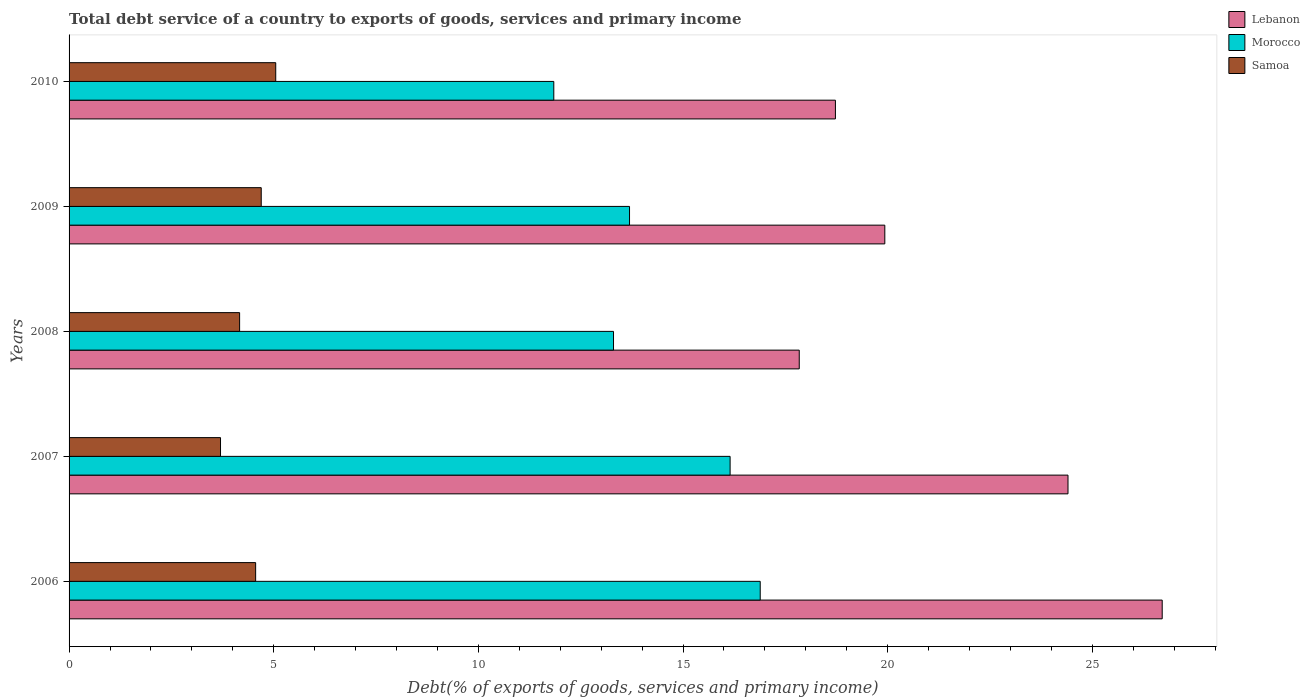How many different coloured bars are there?
Keep it short and to the point. 3. Are the number of bars per tick equal to the number of legend labels?
Ensure brevity in your answer.  Yes. Are the number of bars on each tick of the Y-axis equal?
Your answer should be compact. Yes. How many bars are there on the 1st tick from the top?
Your answer should be very brief. 3. How many bars are there on the 3rd tick from the bottom?
Your answer should be compact. 3. What is the label of the 2nd group of bars from the top?
Your answer should be very brief. 2009. What is the total debt service in Morocco in 2007?
Offer a terse response. 16.15. Across all years, what is the maximum total debt service in Morocco?
Ensure brevity in your answer.  16.89. Across all years, what is the minimum total debt service in Samoa?
Ensure brevity in your answer.  3.7. In which year was the total debt service in Morocco minimum?
Provide a short and direct response. 2010. What is the total total debt service in Morocco in the graph?
Offer a terse response. 71.88. What is the difference between the total debt service in Samoa in 2006 and that in 2007?
Your answer should be very brief. 0.86. What is the difference between the total debt service in Samoa in 2008 and the total debt service in Lebanon in 2007?
Offer a very short reply. -20.24. What is the average total debt service in Lebanon per year?
Your answer should be compact. 21.52. In the year 2010, what is the difference between the total debt service in Samoa and total debt service in Morocco?
Keep it short and to the point. -6.79. What is the ratio of the total debt service in Lebanon in 2008 to that in 2010?
Keep it short and to the point. 0.95. Is the total debt service in Samoa in 2008 less than that in 2010?
Your answer should be compact. Yes. Is the difference between the total debt service in Samoa in 2007 and 2010 greater than the difference between the total debt service in Morocco in 2007 and 2010?
Provide a succinct answer. No. What is the difference between the highest and the second highest total debt service in Lebanon?
Your answer should be compact. 2.3. What is the difference between the highest and the lowest total debt service in Morocco?
Your response must be concise. 5.04. Is the sum of the total debt service in Lebanon in 2006 and 2010 greater than the maximum total debt service in Samoa across all years?
Your response must be concise. Yes. What does the 3rd bar from the top in 2006 represents?
Provide a short and direct response. Lebanon. What does the 3rd bar from the bottom in 2007 represents?
Give a very brief answer. Samoa. Is it the case that in every year, the sum of the total debt service in Morocco and total debt service in Samoa is greater than the total debt service in Lebanon?
Offer a terse response. No. How many bars are there?
Keep it short and to the point. 15. What is the difference between two consecutive major ticks on the X-axis?
Keep it short and to the point. 5. Are the values on the major ticks of X-axis written in scientific E-notation?
Keep it short and to the point. No. Where does the legend appear in the graph?
Ensure brevity in your answer.  Top right. What is the title of the graph?
Your response must be concise. Total debt service of a country to exports of goods, services and primary income. What is the label or title of the X-axis?
Your answer should be compact. Debt(% of exports of goods, services and primary income). What is the label or title of the Y-axis?
Offer a terse response. Years. What is the Debt(% of exports of goods, services and primary income) of Lebanon in 2006?
Offer a very short reply. 26.71. What is the Debt(% of exports of goods, services and primary income) in Morocco in 2006?
Your answer should be compact. 16.89. What is the Debt(% of exports of goods, services and primary income) in Samoa in 2006?
Offer a very short reply. 4.56. What is the Debt(% of exports of goods, services and primary income) of Lebanon in 2007?
Give a very brief answer. 24.41. What is the Debt(% of exports of goods, services and primary income) in Morocco in 2007?
Give a very brief answer. 16.15. What is the Debt(% of exports of goods, services and primary income) of Samoa in 2007?
Give a very brief answer. 3.7. What is the Debt(% of exports of goods, services and primary income) in Lebanon in 2008?
Provide a short and direct response. 17.84. What is the Debt(% of exports of goods, services and primary income) of Morocco in 2008?
Your response must be concise. 13.3. What is the Debt(% of exports of goods, services and primary income) of Samoa in 2008?
Provide a short and direct response. 4.17. What is the Debt(% of exports of goods, services and primary income) in Lebanon in 2009?
Your response must be concise. 19.93. What is the Debt(% of exports of goods, services and primary income) of Morocco in 2009?
Give a very brief answer. 13.69. What is the Debt(% of exports of goods, services and primary income) of Samoa in 2009?
Make the answer very short. 4.7. What is the Debt(% of exports of goods, services and primary income) of Lebanon in 2010?
Offer a very short reply. 18.72. What is the Debt(% of exports of goods, services and primary income) of Morocco in 2010?
Your answer should be compact. 11.84. What is the Debt(% of exports of goods, services and primary income) in Samoa in 2010?
Offer a terse response. 5.05. Across all years, what is the maximum Debt(% of exports of goods, services and primary income) of Lebanon?
Keep it short and to the point. 26.71. Across all years, what is the maximum Debt(% of exports of goods, services and primary income) in Morocco?
Keep it short and to the point. 16.89. Across all years, what is the maximum Debt(% of exports of goods, services and primary income) of Samoa?
Your response must be concise. 5.05. Across all years, what is the minimum Debt(% of exports of goods, services and primary income) of Lebanon?
Offer a terse response. 17.84. Across all years, what is the minimum Debt(% of exports of goods, services and primary income) in Morocco?
Your answer should be compact. 11.84. Across all years, what is the minimum Debt(% of exports of goods, services and primary income) of Samoa?
Give a very brief answer. 3.7. What is the total Debt(% of exports of goods, services and primary income) in Lebanon in the graph?
Provide a short and direct response. 107.61. What is the total Debt(% of exports of goods, services and primary income) in Morocco in the graph?
Your response must be concise. 71.88. What is the total Debt(% of exports of goods, services and primary income) in Samoa in the graph?
Offer a terse response. 22.17. What is the difference between the Debt(% of exports of goods, services and primary income) of Lebanon in 2006 and that in 2007?
Offer a very short reply. 2.3. What is the difference between the Debt(% of exports of goods, services and primary income) in Morocco in 2006 and that in 2007?
Offer a terse response. 0.74. What is the difference between the Debt(% of exports of goods, services and primary income) in Samoa in 2006 and that in 2007?
Ensure brevity in your answer.  0.86. What is the difference between the Debt(% of exports of goods, services and primary income) of Lebanon in 2006 and that in 2008?
Ensure brevity in your answer.  8.87. What is the difference between the Debt(% of exports of goods, services and primary income) of Morocco in 2006 and that in 2008?
Offer a very short reply. 3.58. What is the difference between the Debt(% of exports of goods, services and primary income) of Samoa in 2006 and that in 2008?
Make the answer very short. 0.39. What is the difference between the Debt(% of exports of goods, services and primary income) of Lebanon in 2006 and that in 2009?
Offer a very short reply. 6.78. What is the difference between the Debt(% of exports of goods, services and primary income) of Morocco in 2006 and that in 2009?
Offer a terse response. 3.19. What is the difference between the Debt(% of exports of goods, services and primary income) of Samoa in 2006 and that in 2009?
Offer a terse response. -0.14. What is the difference between the Debt(% of exports of goods, services and primary income) of Lebanon in 2006 and that in 2010?
Offer a very short reply. 7.98. What is the difference between the Debt(% of exports of goods, services and primary income) of Morocco in 2006 and that in 2010?
Your response must be concise. 5.04. What is the difference between the Debt(% of exports of goods, services and primary income) of Samoa in 2006 and that in 2010?
Give a very brief answer. -0.49. What is the difference between the Debt(% of exports of goods, services and primary income) of Lebanon in 2007 and that in 2008?
Ensure brevity in your answer.  6.57. What is the difference between the Debt(% of exports of goods, services and primary income) of Morocco in 2007 and that in 2008?
Keep it short and to the point. 2.85. What is the difference between the Debt(% of exports of goods, services and primary income) in Samoa in 2007 and that in 2008?
Offer a very short reply. -0.47. What is the difference between the Debt(% of exports of goods, services and primary income) of Lebanon in 2007 and that in 2009?
Your response must be concise. 4.48. What is the difference between the Debt(% of exports of goods, services and primary income) of Morocco in 2007 and that in 2009?
Ensure brevity in your answer.  2.46. What is the difference between the Debt(% of exports of goods, services and primary income) of Samoa in 2007 and that in 2009?
Give a very brief answer. -0.99. What is the difference between the Debt(% of exports of goods, services and primary income) of Lebanon in 2007 and that in 2010?
Offer a very short reply. 5.68. What is the difference between the Debt(% of exports of goods, services and primary income) in Morocco in 2007 and that in 2010?
Ensure brevity in your answer.  4.31. What is the difference between the Debt(% of exports of goods, services and primary income) in Samoa in 2007 and that in 2010?
Provide a short and direct response. -1.35. What is the difference between the Debt(% of exports of goods, services and primary income) in Lebanon in 2008 and that in 2009?
Offer a terse response. -2.09. What is the difference between the Debt(% of exports of goods, services and primary income) in Morocco in 2008 and that in 2009?
Your answer should be compact. -0.39. What is the difference between the Debt(% of exports of goods, services and primary income) of Samoa in 2008 and that in 2009?
Provide a short and direct response. -0.53. What is the difference between the Debt(% of exports of goods, services and primary income) of Lebanon in 2008 and that in 2010?
Ensure brevity in your answer.  -0.88. What is the difference between the Debt(% of exports of goods, services and primary income) in Morocco in 2008 and that in 2010?
Provide a succinct answer. 1.46. What is the difference between the Debt(% of exports of goods, services and primary income) of Samoa in 2008 and that in 2010?
Make the answer very short. -0.88. What is the difference between the Debt(% of exports of goods, services and primary income) in Lebanon in 2009 and that in 2010?
Offer a very short reply. 1.21. What is the difference between the Debt(% of exports of goods, services and primary income) of Morocco in 2009 and that in 2010?
Make the answer very short. 1.85. What is the difference between the Debt(% of exports of goods, services and primary income) in Samoa in 2009 and that in 2010?
Give a very brief answer. -0.35. What is the difference between the Debt(% of exports of goods, services and primary income) of Lebanon in 2006 and the Debt(% of exports of goods, services and primary income) of Morocco in 2007?
Ensure brevity in your answer.  10.56. What is the difference between the Debt(% of exports of goods, services and primary income) of Lebanon in 2006 and the Debt(% of exports of goods, services and primary income) of Samoa in 2007?
Your answer should be very brief. 23.01. What is the difference between the Debt(% of exports of goods, services and primary income) of Morocco in 2006 and the Debt(% of exports of goods, services and primary income) of Samoa in 2007?
Ensure brevity in your answer.  13.19. What is the difference between the Debt(% of exports of goods, services and primary income) of Lebanon in 2006 and the Debt(% of exports of goods, services and primary income) of Morocco in 2008?
Provide a succinct answer. 13.41. What is the difference between the Debt(% of exports of goods, services and primary income) of Lebanon in 2006 and the Debt(% of exports of goods, services and primary income) of Samoa in 2008?
Your answer should be compact. 22.54. What is the difference between the Debt(% of exports of goods, services and primary income) in Morocco in 2006 and the Debt(% of exports of goods, services and primary income) in Samoa in 2008?
Offer a very short reply. 12.72. What is the difference between the Debt(% of exports of goods, services and primary income) of Lebanon in 2006 and the Debt(% of exports of goods, services and primary income) of Morocco in 2009?
Your answer should be compact. 13.01. What is the difference between the Debt(% of exports of goods, services and primary income) of Lebanon in 2006 and the Debt(% of exports of goods, services and primary income) of Samoa in 2009?
Your response must be concise. 22.01. What is the difference between the Debt(% of exports of goods, services and primary income) in Morocco in 2006 and the Debt(% of exports of goods, services and primary income) in Samoa in 2009?
Your answer should be very brief. 12.19. What is the difference between the Debt(% of exports of goods, services and primary income) of Lebanon in 2006 and the Debt(% of exports of goods, services and primary income) of Morocco in 2010?
Provide a succinct answer. 14.86. What is the difference between the Debt(% of exports of goods, services and primary income) of Lebanon in 2006 and the Debt(% of exports of goods, services and primary income) of Samoa in 2010?
Provide a short and direct response. 21.66. What is the difference between the Debt(% of exports of goods, services and primary income) of Morocco in 2006 and the Debt(% of exports of goods, services and primary income) of Samoa in 2010?
Give a very brief answer. 11.84. What is the difference between the Debt(% of exports of goods, services and primary income) in Lebanon in 2007 and the Debt(% of exports of goods, services and primary income) in Morocco in 2008?
Provide a succinct answer. 11.1. What is the difference between the Debt(% of exports of goods, services and primary income) in Lebanon in 2007 and the Debt(% of exports of goods, services and primary income) in Samoa in 2008?
Provide a succinct answer. 20.24. What is the difference between the Debt(% of exports of goods, services and primary income) of Morocco in 2007 and the Debt(% of exports of goods, services and primary income) of Samoa in 2008?
Provide a short and direct response. 11.98. What is the difference between the Debt(% of exports of goods, services and primary income) in Lebanon in 2007 and the Debt(% of exports of goods, services and primary income) in Morocco in 2009?
Offer a very short reply. 10.71. What is the difference between the Debt(% of exports of goods, services and primary income) in Lebanon in 2007 and the Debt(% of exports of goods, services and primary income) in Samoa in 2009?
Provide a succinct answer. 19.71. What is the difference between the Debt(% of exports of goods, services and primary income) in Morocco in 2007 and the Debt(% of exports of goods, services and primary income) in Samoa in 2009?
Make the answer very short. 11.46. What is the difference between the Debt(% of exports of goods, services and primary income) in Lebanon in 2007 and the Debt(% of exports of goods, services and primary income) in Morocco in 2010?
Provide a short and direct response. 12.56. What is the difference between the Debt(% of exports of goods, services and primary income) of Lebanon in 2007 and the Debt(% of exports of goods, services and primary income) of Samoa in 2010?
Offer a very short reply. 19.36. What is the difference between the Debt(% of exports of goods, services and primary income) in Morocco in 2007 and the Debt(% of exports of goods, services and primary income) in Samoa in 2010?
Provide a succinct answer. 11.1. What is the difference between the Debt(% of exports of goods, services and primary income) in Lebanon in 2008 and the Debt(% of exports of goods, services and primary income) in Morocco in 2009?
Your response must be concise. 4.15. What is the difference between the Debt(% of exports of goods, services and primary income) in Lebanon in 2008 and the Debt(% of exports of goods, services and primary income) in Samoa in 2009?
Provide a short and direct response. 13.15. What is the difference between the Debt(% of exports of goods, services and primary income) in Morocco in 2008 and the Debt(% of exports of goods, services and primary income) in Samoa in 2009?
Make the answer very short. 8.61. What is the difference between the Debt(% of exports of goods, services and primary income) in Lebanon in 2008 and the Debt(% of exports of goods, services and primary income) in Morocco in 2010?
Your answer should be very brief. 6. What is the difference between the Debt(% of exports of goods, services and primary income) in Lebanon in 2008 and the Debt(% of exports of goods, services and primary income) in Samoa in 2010?
Your answer should be compact. 12.79. What is the difference between the Debt(% of exports of goods, services and primary income) in Morocco in 2008 and the Debt(% of exports of goods, services and primary income) in Samoa in 2010?
Your answer should be compact. 8.25. What is the difference between the Debt(% of exports of goods, services and primary income) in Lebanon in 2009 and the Debt(% of exports of goods, services and primary income) in Morocco in 2010?
Make the answer very short. 8.09. What is the difference between the Debt(% of exports of goods, services and primary income) of Lebanon in 2009 and the Debt(% of exports of goods, services and primary income) of Samoa in 2010?
Make the answer very short. 14.88. What is the difference between the Debt(% of exports of goods, services and primary income) in Morocco in 2009 and the Debt(% of exports of goods, services and primary income) in Samoa in 2010?
Ensure brevity in your answer.  8.64. What is the average Debt(% of exports of goods, services and primary income) in Lebanon per year?
Offer a very short reply. 21.52. What is the average Debt(% of exports of goods, services and primary income) of Morocco per year?
Make the answer very short. 14.38. What is the average Debt(% of exports of goods, services and primary income) of Samoa per year?
Your answer should be compact. 4.43. In the year 2006, what is the difference between the Debt(% of exports of goods, services and primary income) of Lebanon and Debt(% of exports of goods, services and primary income) of Morocco?
Ensure brevity in your answer.  9.82. In the year 2006, what is the difference between the Debt(% of exports of goods, services and primary income) in Lebanon and Debt(% of exports of goods, services and primary income) in Samoa?
Your answer should be very brief. 22.15. In the year 2006, what is the difference between the Debt(% of exports of goods, services and primary income) of Morocco and Debt(% of exports of goods, services and primary income) of Samoa?
Make the answer very short. 12.33. In the year 2007, what is the difference between the Debt(% of exports of goods, services and primary income) of Lebanon and Debt(% of exports of goods, services and primary income) of Morocco?
Offer a very short reply. 8.26. In the year 2007, what is the difference between the Debt(% of exports of goods, services and primary income) in Lebanon and Debt(% of exports of goods, services and primary income) in Samoa?
Offer a very short reply. 20.71. In the year 2007, what is the difference between the Debt(% of exports of goods, services and primary income) in Morocco and Debt(% of exports of goods, services and primary income) in Samoa?
Your answer should be compact. 12.45. In the year 2008, what is the difference between the Debt(% of exports of goods, services and primary income) of Lebanon and Debt(% of exports of goods, services and primary income) of Morocco?
Offer a terse response. 4.54. In the year 2008, what is the difference between the Debt(% of exports of goods, services and primary income) in Lebanon and Debt(% of exports of goods, services and primary income) in Samoa?
Your answer should be very brief. 13.67. In the year 2008, what is the difference between the Debt(% of exports of goods, services and primary income) in Morocco and Debt(% of exports of goods, services and primary income) in Samoa?
Give a very brief answer. 9.14. In the year 2009, what is the difference between the Debt(% of exports of goods, services and primary income) of Lebanon and Debt(% of exports of goods, services and primary income) of Morocco?
Provide a succinct answer. 6.24. In the year 2009, what is the difference between the Debt(% of exports of goods, services and primary income) in Lebanon and Debt(% of exports of goods, services and primary income) in Samoa?
Give a very brief answer. 15.24. In the year 2009, what is the difference between the Debt(% of exports of goods, services and primary income) in Morocco and Debt(% of exports of goods, services and primary income) in Samoa?
Give a very brief answer. 9. In the year 2010, what is the difference between the Debt(% of exports of goods, services and primary income) in Lebanon and Debt(% of exports of goods, services and primary income) in Morocco?
Keep it short and to the point. 6.88. In the year 2010, what is the difference between the Debt(% of exports of goods, services and primary income) of Lebanon and Debt(% of exports of goods, services and primary income) of Samoa?
Make the answer very short. 13.67. In the year 2010, what is the difference between the Debt(% of exports of goods, services and primary income) in Morocco and Debt(% of exports of goods, services and primary income) in Samoa?
Make the answer very short. 6.79. What is the ratio of the Debt(% of exports of goods, services and primary income) of Lebanon in 2006 to that in 2007?
Provide a short and direct response. 1.09. What is the ratio of the Debt(% of exports of goods, services and primary income) in Morocco in 2006 to that in 2007?
Provide a succinct answer. 1.05. What is the ratio of the Debt(% of exports of goods, services and primary income) in Samoa in 2006 to that in 2007?
Provide a succinct answer. 1.23. What is the ratio of the Debt(% of exports of goods, services and primary income) in Lebanon in 2006 to that in 2008?
Ensure brevity in your answer.  1.5. What is the ratio of the Debt(% of exports of goods, services and primary income) of Morocco in 2006 to that in 2008?
Provide a succinct answer. 1.27. What is the ratio of the Debt(% of exports of goods, services and primary income) in Samoa in 2006 to that in 2008?
Give a very brief answer. 1.09. What is the ratio of the Debt(% of exports of goods, services and primary income) of Lebanon in 2006 to that in 2009?
Your answer should be compact. 1.34. What is the ratio of the Debt(% of exports of goods, services and primary income) in Morocco in 2006 to that in 2009?
Offer a very short reply. 1.23. What is the ratio of the Debt(% of exports of goods, services and primary income) of Samoa in 2006 to that in 2009?
Ensure brevity in your answer.  0.97. What is the ratio of the Debt(% of exports of goods, services and primary income) of Lebanon in 2006 to that in 2010?
Provide a short and direct response. 1.43. What is the ratio of the Debt(% of exports of goods, services and primary income) in Morocco in 2006 to that in 2010?
Provide a succinct answer. 1.43. What is the ratio of the Debt(% of exports of goods, services and primary income) in Samoa in 2006 to that in 2010?
Give a very brief answer. 0.9. What is the ratio of the Debt(% of exports of goods, services and primary income) of Lebanon in 2007 to that in 2008?
Make the answer very short. 1.37. What is the ratio of the Debt(% of exports of goods, services and primary income) of Morocco in 2007 to that in 2008?
Offer a terse response. 1.21. What is the ratio of the Debt(% of exports of goods, services and primary income) of Samoa in 2007 to that in 2008?
Make the answer very short. 0.89. What is the ratio of the Debt(% of exports of goods, services and primary income) in Lebanon in 2007 to that in 2009?
Offer a very short reply. 1.22. What is the ratio of the Debt(% of exports of goods, services and primary income) in Morocco in 2007 to that in 2009?
Give a very brief answer. 1.18. What is the ratio of the Debt(% of exports of goods, services and primary income) of Samoa in 2007 to that in 2009?
Ensure brevity in your answer.  0.79. What is the ratio of the Debt(% of exports of goods, services and primary income) in Lebanon in 2007 to that in 2010?
Provide a short and direct response. 1.3. What is the ratio of the Debt(% of exports of goods, services and primary income) in Morocco in 2007 to that in 2010?
Ensure brevity in your answer.  1.36. What is the ratio of the Debt(% of exports of goods, services and primary income) of Samoa in 2007 to that in 2010?
Ensure brevity in your answer.  0.73. What is the ratio of the Debt(% of exports of goods, services and primary income) in Lebanon in 2008 to that in 2009?
Your answer should be very brief. 0.9. What is the ratio of the Debt(% of exports of goods, services and primary income) of Morocco in 2008 to that in 2009?
Your answer should be compact. 0.97. What is the ratio of the Debt(% of exports of goods, services and primary income) in Samoa in 2008 to that in 2009?
Provide a short and direct response. 0.89. What is the ratio of the Debt(% of exports of goods, services and primary income) of Lebanon in 2008 to that in 2010?
Your answer should be very brief. 0.95. What is the ratio of the Debt(% of exports of goods, services and primary income) of Morocco in 2008 to that in 2010?
Ensure brevity in your answer.  1.12. What is the ratio of the Debt(% of exports of goods, services and primary income) in Samoa in 2008 to that in 2010?
Keep it short and to the point. 0.83. What is the ratio of the Debt(% of exports of goods, services and primary income) of Lebanon in 2009 to that in 2010?
Your answer should be compact. 1.06. What is the ratio of the Debt(% of exports of goods, services and primary income) in Morocco in 2009 to that in 2010?
Your answer should be compact. 1.16. What is the ratio of the Debt(% of exports of goods, services and primary income) of Samoa in 2009 to that in 2010?
Ensure brevity in your answer.  0.93. What is the difference between the highest and the second highest Debt(% of exports of goods, services and primary income) in Lebanon?
Give a very brief answer. 2.3. What is the difference between the highest and the second highest Debt(% of exports of goods, services and primary income) of Morocco?
Offer a terse response. 0.74. What is the difference between the highest and the second highest Debt(% of exports of goods, services and primary income) in Samoa?
Your answer should be very brief. 0.35. What is the difference between the highest and the lowest Debt(% of exports of goods, services and primary income) in Lebanon?
Make the answer very short. 8.87. What is the difference between the highest and the lowest Debt(% of exports of goods, services and primary income) in Morocco?
Make the answer very short. 5.04. What is the difference between the highest and the lowest Debt(% of exports of goods, services and primary income) in Samoa?
Provide a short and direct response. 1.35. 